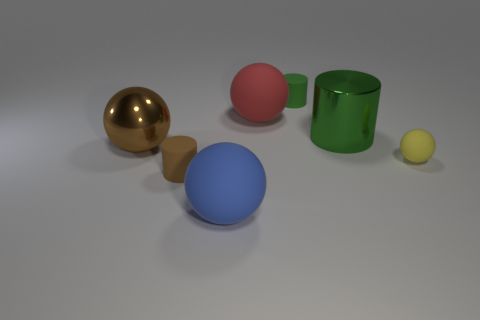Subtract all green cylinders. How many were subtracted if there are1green cylinders left? 1 Subtract all brown shiny spheres. How many spheres are left? 3 Subtract all green cubes. How many green cylinders are left? 2 Add 1 yellow rubber balls. How many objects exist? 8 Subtract 1 cylinders. How many cylinders are left? 2 Subtract all brown balls. How many balls are left? 3 Subtract all cylinders. How many objects are left? 4 Subtract all tiny yellow balls. Subtract all gray objects. How many objects are left? 6 Add 3 large blue objects. How many large blue objects are left? 4 Add 3 green things. How many green things exist? 5 